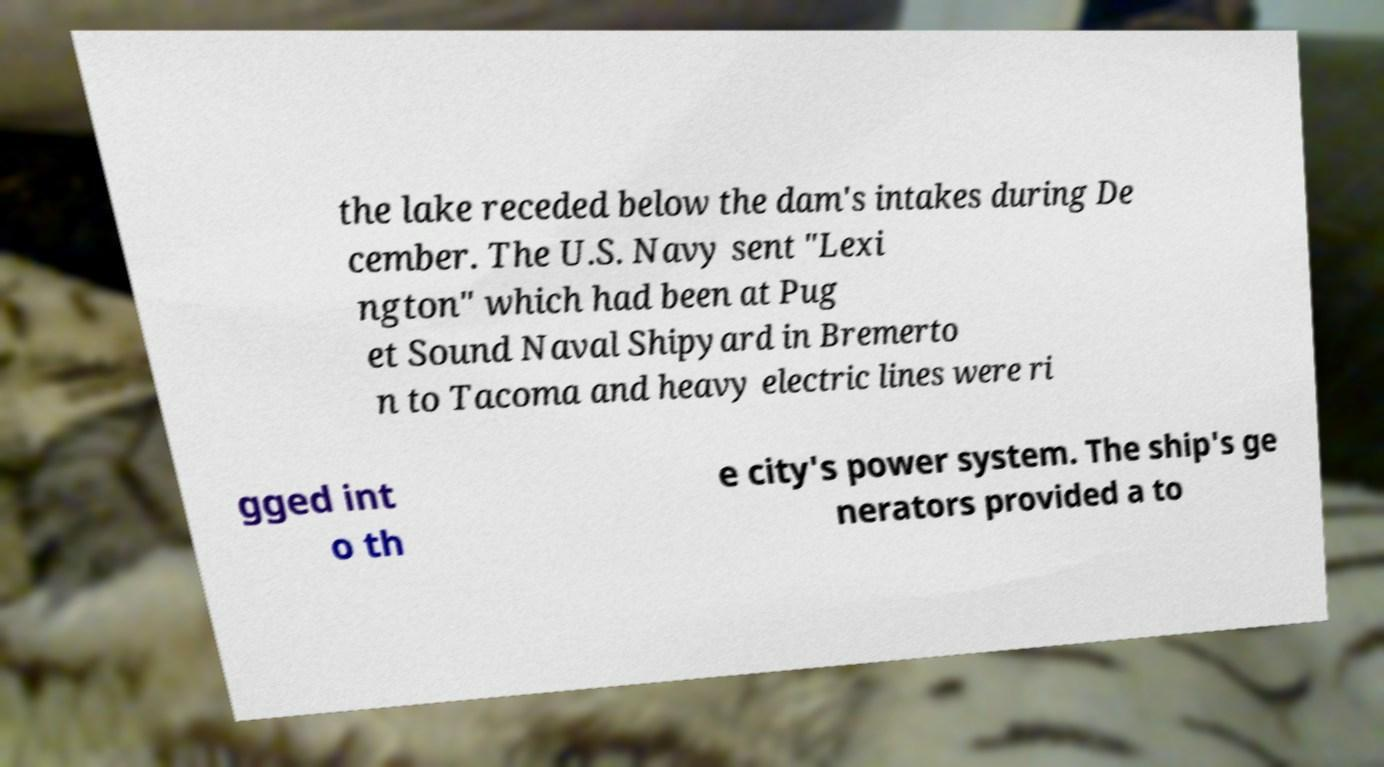Can you accurately transcribe the text from the provided image for me? the lake receded below the dam's intakes during De cember. The U.S. Navy sent "Lexi ngton" which had been at Pug et Sound Naval Shipyard in Bremerto n to Tacoma and heavy electric lines were ri gged int o th e city's power system. The ship's ge nerators provided a to 